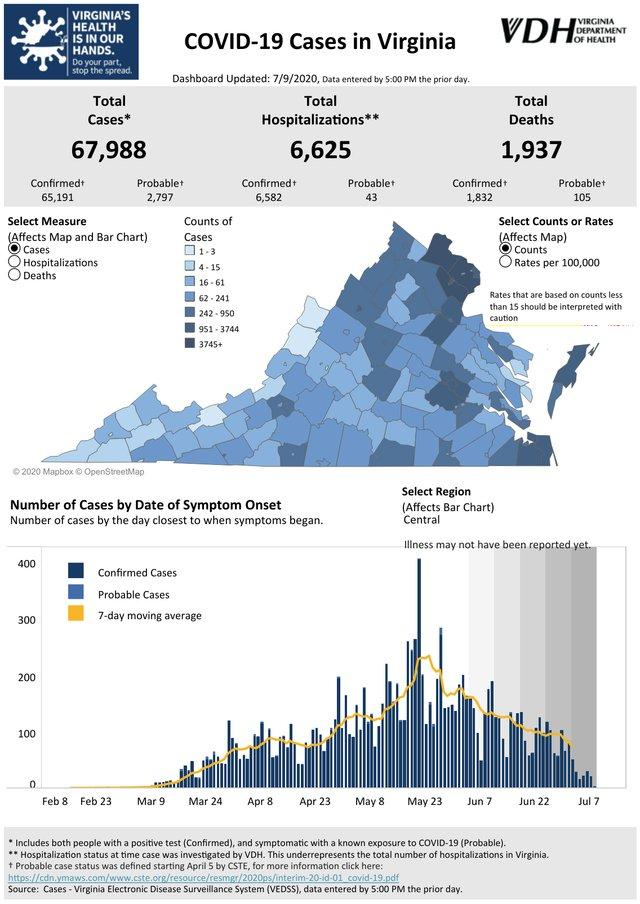Mention a couple of crucial points in this snapshot. As of July 9th, 2020, a total of 6,582 confirmed cases of Covid-19 have been hospitalized in the state of Virginia. As of July 9, 2020, the total number of COVID-19 cases reported in Virginia was 67,988. As of July 9th, 2020, the total number of confirmed COVID-19 cases reported in Virginia is 65,191. As of July 9, 2020, a total of 1,937 Covid-19 deaths had been reported in the state of Virginia. 